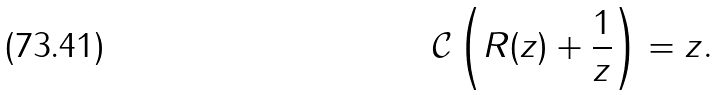<formula> <loc_0><loc_0><loc_500><loc_500>\mathcal { C } \left ( { R } ( z ) + \frac { 1 } { z } \right ) = z .</formula> 